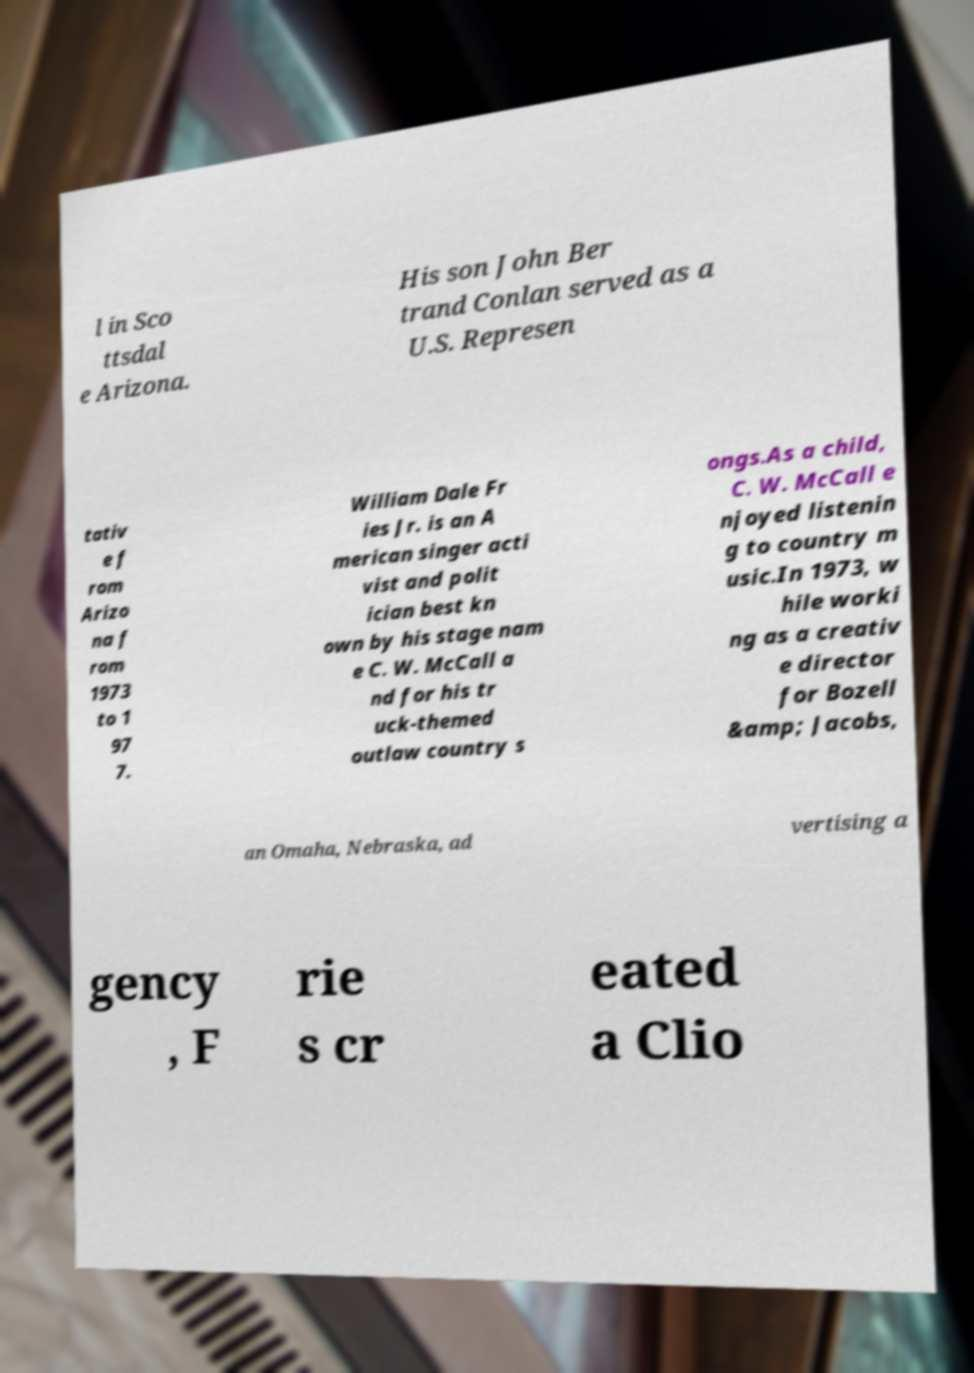Can you accurately transcribe the text from the provided image for me? l in Sco ttsdal e Arizona. His son John Ber trand Conlan served as a U.S. Represen tativ e f rom Arizo na f rom 1973 to 1 97 7. William Dale Fr ies Jr. is an A merican singer acti vist and polit ician best kn own by his stage nam e C. W. McCall a nd for his tr uck-themed outlaw country s ongs.As a child, C. W. McCall e njoyed listenin g to country m usic.In 1973, w hile worki ng as a creativ e director for Bozell &amp; Jacobs, an Omaha, Nebraska, ad vertising a gency , F rie s cr eated a Clio 